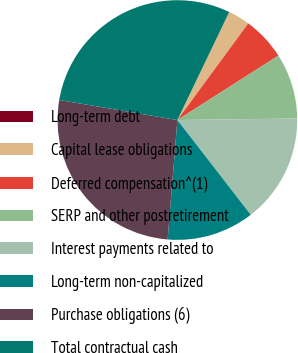<chart> <loc_0><loc_0><loc_500><loc_500><pie_chart><fcel>Long-term debt<fcel>Capital lease obligations<fcel>Deferred compensation^(1)<fcel>SERP and other postretirement<fcel>Interest payments related to<fcel>Long-term non-capitalized<fcel>Purchase obligations (6)<fcel>Total contractual cash<nl><fcel>0.0%<fcel>2.95%<fcel>5.89%<fcel>8.83%<fcel>14.72%<fcel>11.78%<fcel>26.38%<fcel>29.44%<nl></chart> 